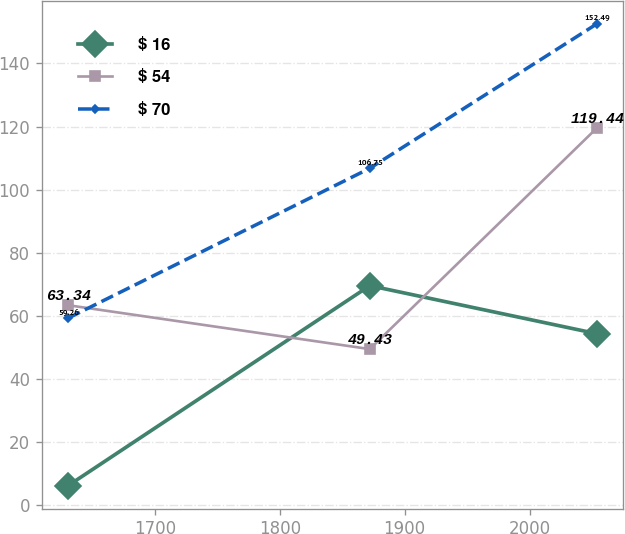Convert chart. <chart><loc_0><loc_0><loc_500><loc_500><line_chart><ecel><fcel>$ 16<fcel>$ 54<fcel>$ 70<nl><fcel>1630.72<fcel>6.15<fcel>63.34<fcel>59.26<nl><fcel>1872.09<fcel>69.54<fcel>49.43<fcel>106.75<nl><fcel>2053.6<fcel>54.33<fcel>119.44<fcel>152.49<nl></chart> 